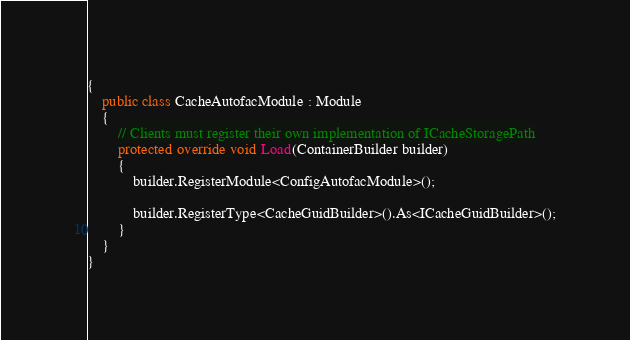Convert code to text. <code><loc_0><loc_0><loc_500><loc_500><_C#_>{
    public class CacheAutofacModule : Module
    {
        // Clients must register their own implementation of ICacheStoragePath
        protected override void Load(ContainerBuilder builder)
        {
            builder.RegisterModule<ConfigAutofacModule>();

            builder.RegisterType<CacheGuidBuilder>().As<ICacheGuidBuilder>();
        }
    }
}
</code> 